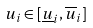<formula> <loc_0><loc_0><loc_500><loc_500>u _ { i } \in [ \underline { u } _ { i } , \overline { u } _ { i } ]</formula> 